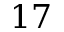<formula> <loc_0><loc_0><loc_500><loc_500>1 7</formula> 